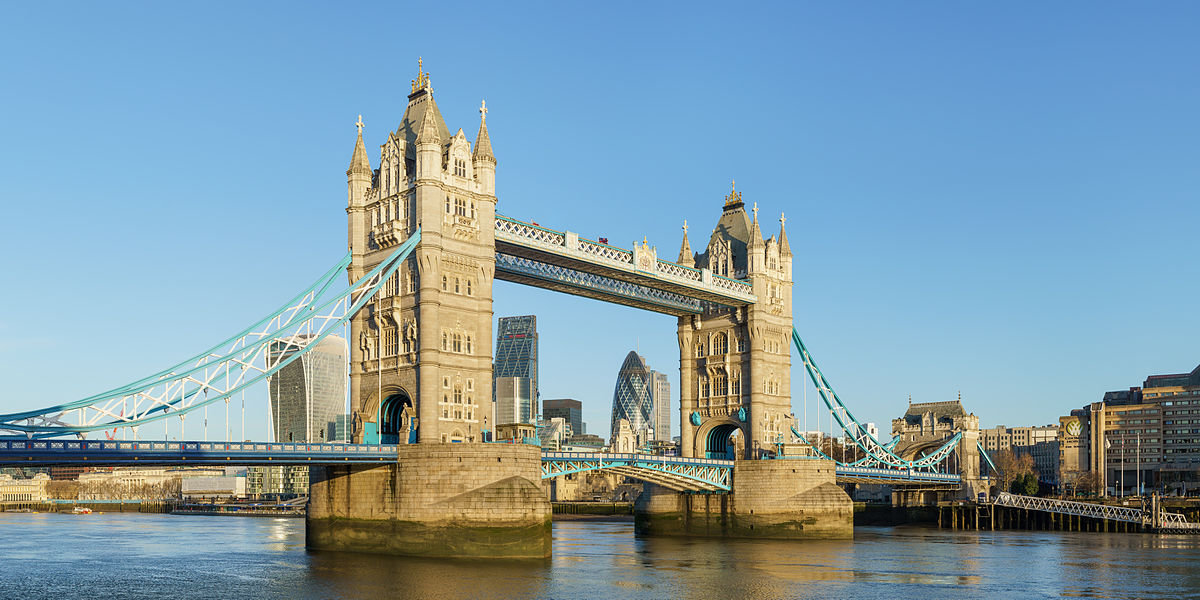What's happening in the scene? The image captures the iconic Tower Bridge in London, England, a testament to the city's rich history and architectural prowess. The bridge, a marvel of Victorian engineering, is a suspension bridge characterized by two robust towers connected by a walkway. The towers, constructed from stone, rise majestically above the Thames River, their pointed roofs adding to their grandeur. The bridge is adorned in a palette of blue and white, colors that stand out against the backdrop of the clear blue sky. The perspective of the photo offers a side view of the bridge, providing a glimpse of the bustling cityscape in the background. The calm waters of the Thames River flow beneath the bridge, reflecting the structure's magnificence. The image encapsulates a typical day in London, with the Tower Bridge standing as a silent sentinel over the ever-evolving city. 